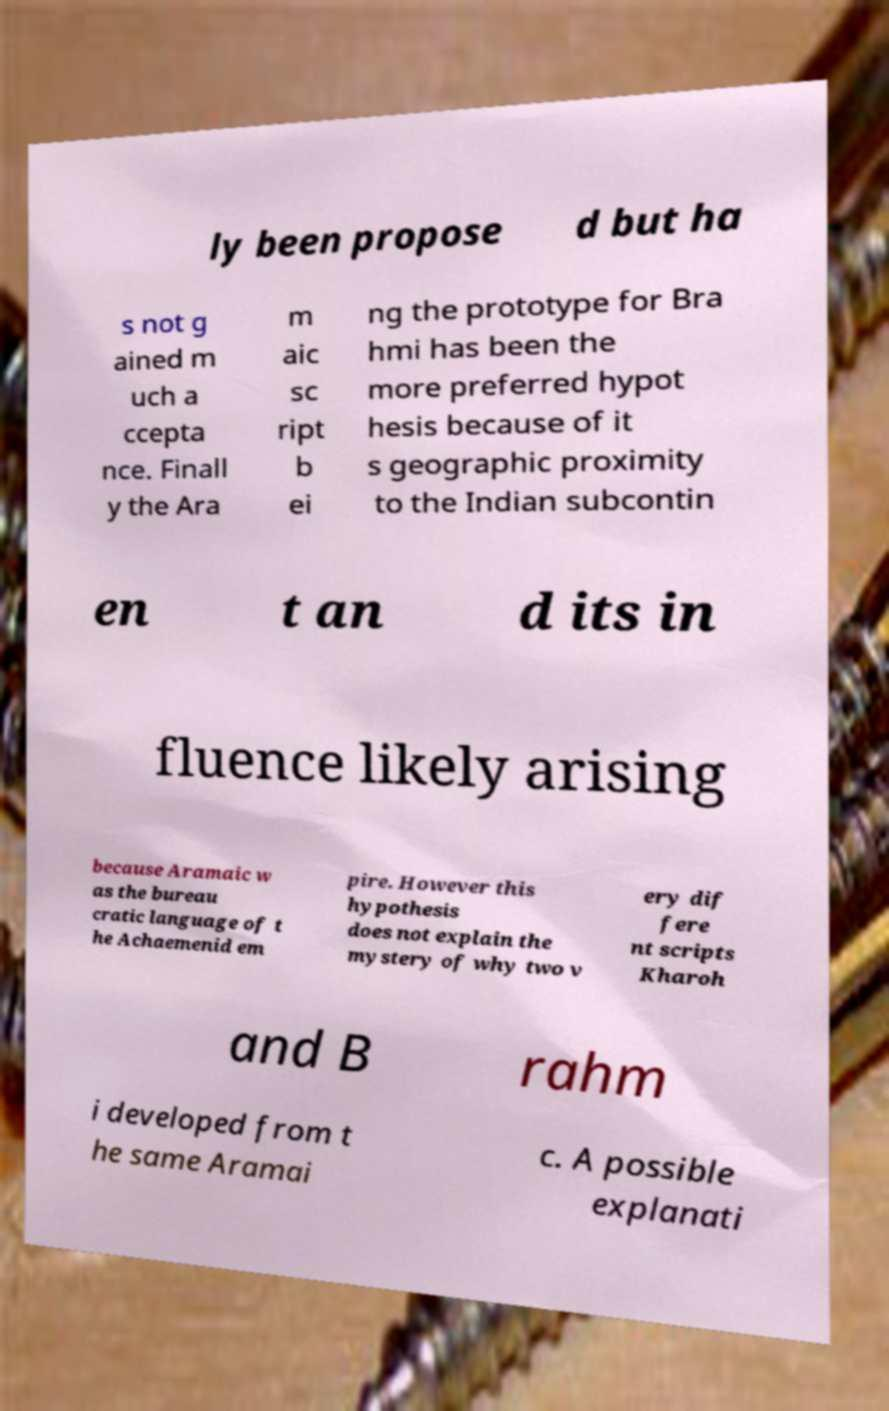Could you assist in decoding the text presented in this image and type it out clearly? ly been propose d but ha s not g ained m uch a ccepta nce. Finall y the Ara m aic sc ript b ei ng the prototype for Bra hmi has been the more preferred hypot hesis because of it s geographic proximity to the Indian subcontin en t an d its in fluence likely arising because Aramaic w as the bureau cratic language of t he Achaemenid em pire. However this hypothesis does not explain the mystery of why two v ery dif fere nt scripts Kharoh and B rahm i developed from t he same Aramai c. A possible explanati 